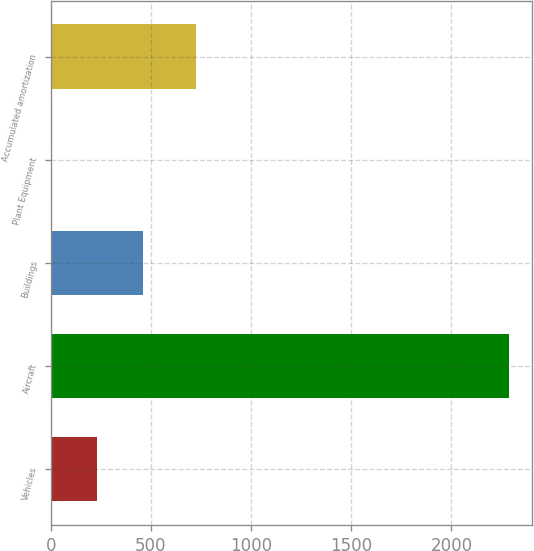<chart> <loc_0><loc_0><loc_500><loc_500><bar_chart><fcel>Vehicles<fcel>Aircraft<fcel>Buildings<fcel>Plant Equipment<fcel>Accumulated amortization<nl><fcel>230.7<fcel>2289<fcel>459.4<fcel>2<fcel>727<nl></chart> 